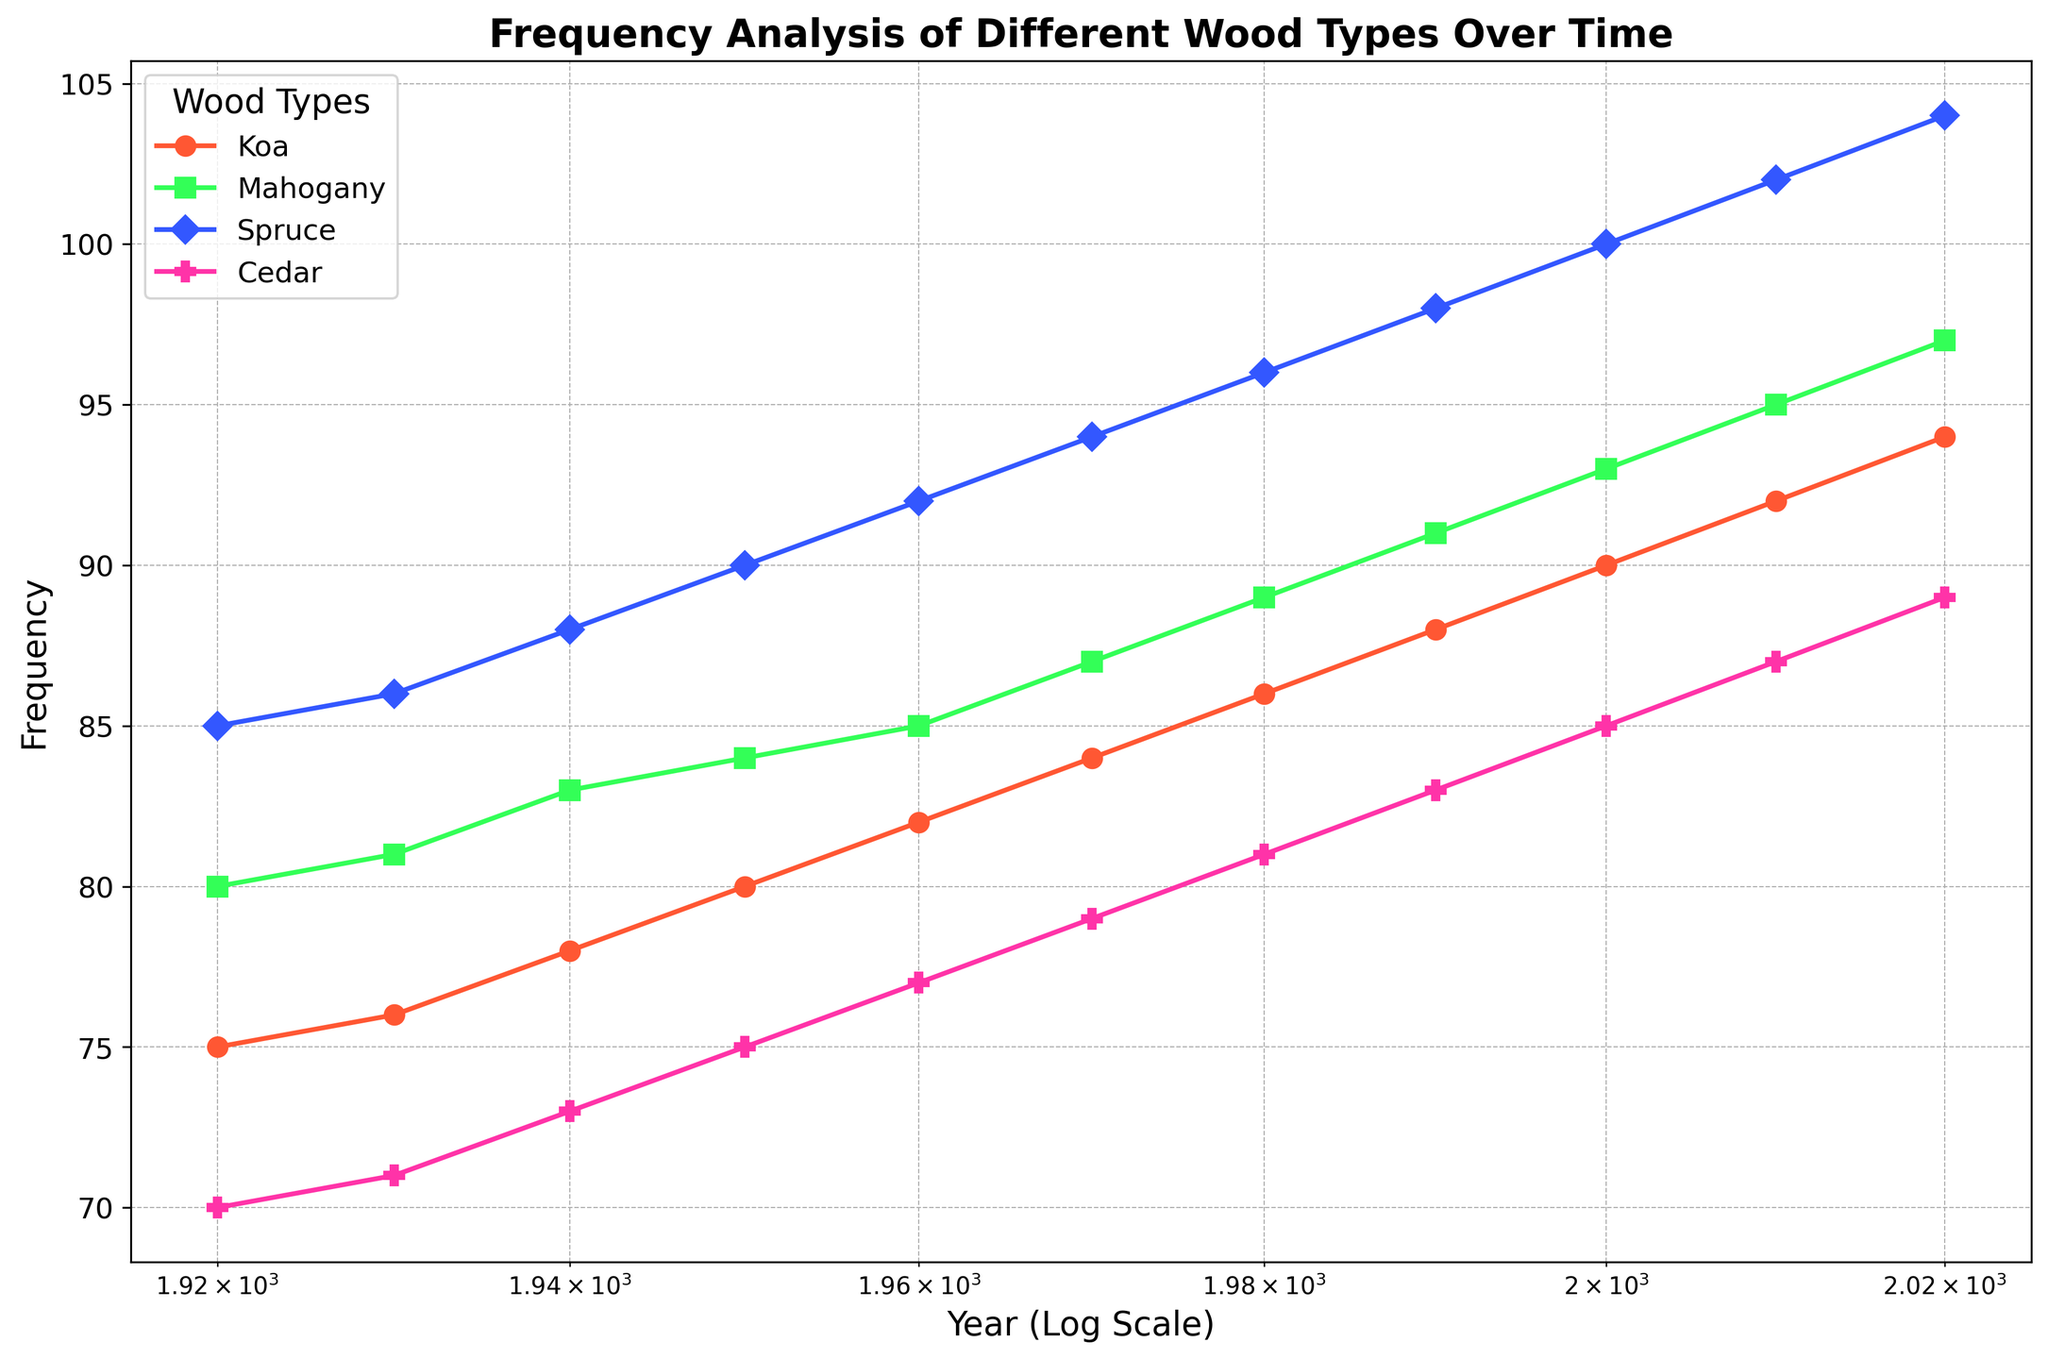Which wood type had the highest frequency in the year 2020? Look at the values for each wood type in the year 2020 on the chart. Spruce has the highest frequency with a value of 104.
Answer: Spruce How did the frequency of Koa wood change from 1930 to 1940? Observe the points for Koa wood in 1930 and 1940. The frequency increased from 76 in 1930 to 78 in 1940.
Answer: Increased by 2 What is the average frequency of Mahogany wood over the examined years? Sum the frequencies of Mahogany wood at each time point (80+81+83+84+85+87+89+91+93+95+97) and divide by the number of data points (11). The total is 965, divided by 11 gives an average of approximately 87.73.
Answer: 87.73 Between Cedar and Spruce, which wood type showed more change in frequency from 1920 to 2020? Calculate the change for Cedar (89-70=19) and for Spruce (104-85=19). Both Cedar and Spruce showed a change of 19 in frequency.
Answer: Both showed equal change Which wood type had its lowest frequency in 1920 and by what amount did its frequency increase by 2020? Look at the frequencies of each wood type in 1920; Cedar has the lowest frequency of 70. By 2020, Cedar's frequency increased to 89, so the increase is (89-70) = 19.
Answer: Cedar, increased by 19 What is the overall trend for Mahogany wood’s frequency over time? Observe the plot for Mahogany wood over the years. It shows a consistent upward trend from 80 in 1920 to 97 in 2020.
Answer: Increasing trend For which wood type and year was there a sudden change in slope on the log scale? On the log scale x-axis, observe the slopes of the frequency lines. No sudden slope change is visually noticeable, indicating a steady change for all wood types over time.
Answer: No sudden change detected What color represents the Koa wood on the chart? Look at the color associated with the label 'Koa' in the legend of the chart. Koa is represented by the red color.
Answer: Red Which wood type has frequencies depicted using diamond markers? Check the legend for the shape of the markers. Spruce is represented by diamond markers.
Answer: Spruce Is there any wood type that consistently had higher frequencies compared to Cedar? Compare the frequencies of each wood type to Cedar across all years. Spruce consistently had higher frequencies than Cedar throughout the years.
Answer: Spruce 